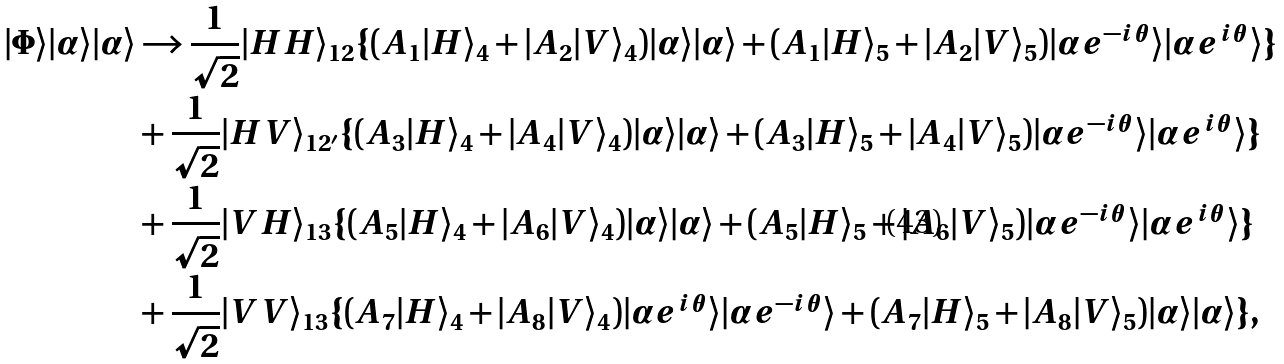Convert formula to latex. <formula><loc_0><loc_0><loc_500><loc_500>| \Phi \rangle | \alpha \rangle | \alpha \rangle & \rightarrow \frac { 1 } { \sqrt { 2 } } | H H \rangle _ { 1 2 } \{ ( A _ { 1 } | H \rangle _ { 4 } + | A _ { 2 } | V \rangle _ { 4 } ) | \alpha \rangle | \alpha \rangle + ( A _ { 1 } | H \rangle _ { 5 } + | A _ { 2 } | V \rangle _ { 5 } ) | \alpha e ^ { - i \theta } \rangle | \alpha e ^ { i \theta } \rangle \} \\ & + \frac { 1 } { \sqrt { 2 } } | H V \rangle _ { 1 2 ^ { \prime } } \{ ( A _ { 3 } | H \rangle _ { 4 } + | A _ { 4 } | V \rangle _ { 4 } ) | \alpha \rangle | \alpha \rangle + ( A _ { 3 } | H \rangle _ { 5 } + | A _ { 4 } | V \rangle _ { 5 } ) | \alpha e ^ { - i \theta } \rangle | \alpha e ^ { i \theta } \rangle \} \\ & + \frac { 1 } { \sqrt { 2 } } | V H \rangle _ { 1 3 } \{ ( A _ { 5 } | H \rangle _ { 4 } + | A _ { 6 } | V \rangle _ { 4 } ) | \alpha \rangle | \alpha \rangle + ( A _ { 5 } | H \rangle _ { 5 } + | A _ { 6 } | V \rangle _ { 5 } ) | \alpha e ^ { - i \theta } \rangle | \alpha e ^ { i \theta } \rangle \} \\ & + \frac { 1 } { \sqrt { 2 } } | V V \rangle _ { 1 3 } \{ ( A _ { 7 } | H \rangle _ { 4 } + | A _ { 8 } | V \rangle _ { 4 } ) | \alpha e ^ { i \theta } \rangle | \alpha e ^ { - i \theta } \rangle + ( A _ { 7 } | H \rangle _ { 5 } + | A _ { 8 } | V \rangle _ { 5 } ) | \alpha \rangle | \alpha \rangle \} ,</formula> 